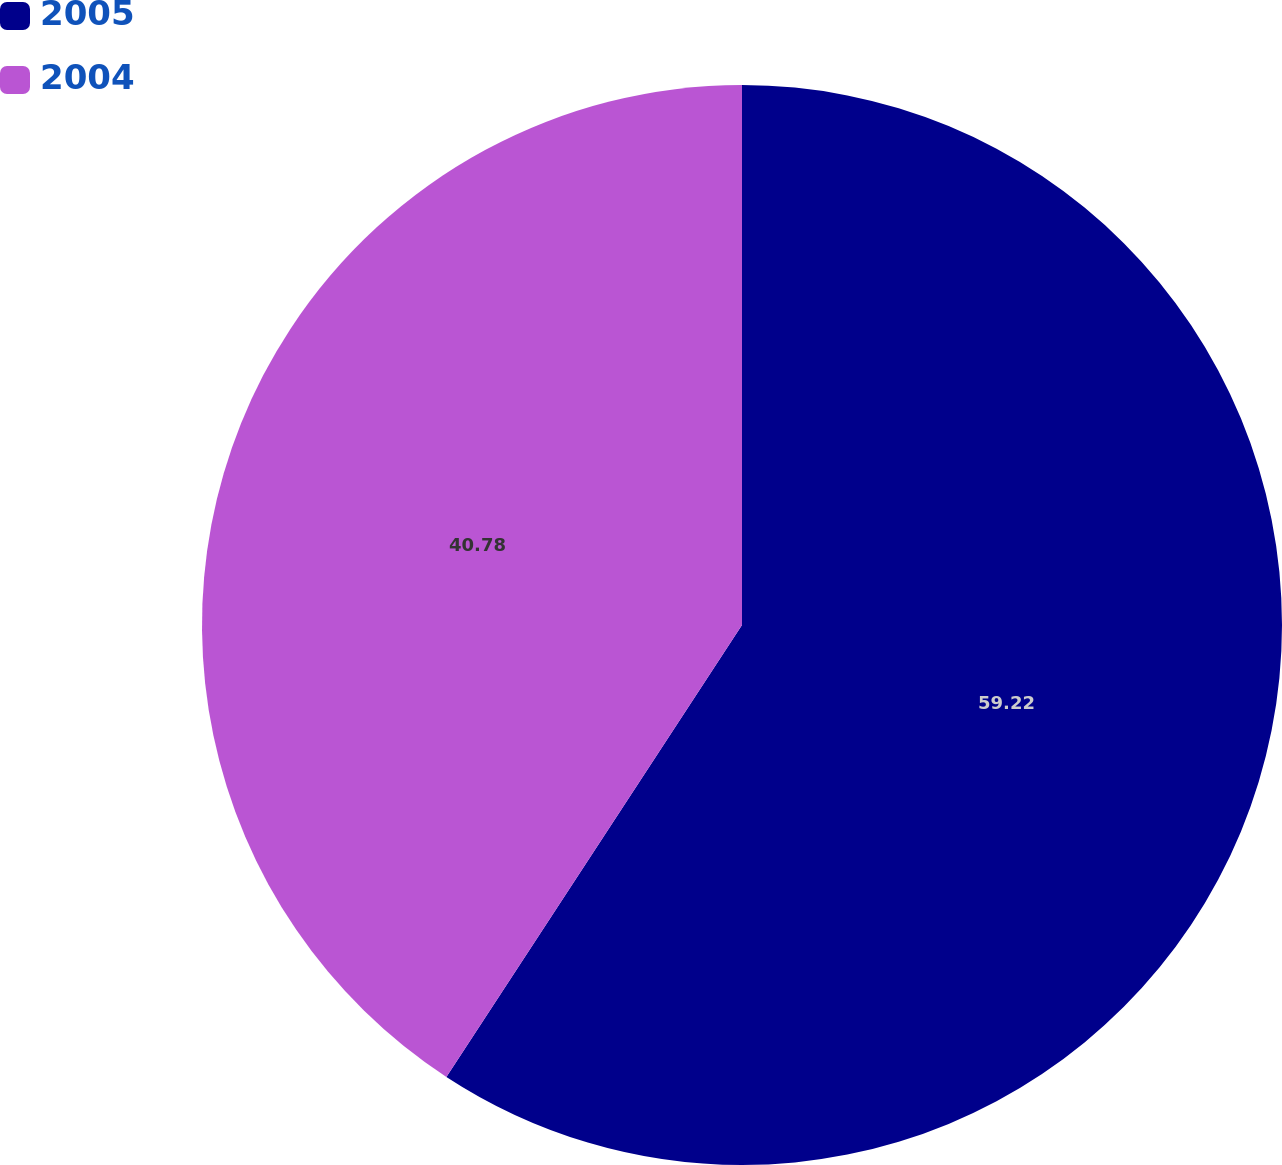Convert chart. <chart><loc_0><loc_0><loc_500><loc_500><pie_chart><fcel>2005<fcel>2004<nl><fcel>59.22%<fcel>40.78%<nl></chart> 